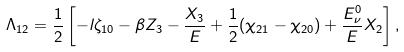Convert formula to latex. <formula><loc_0><loc_0><loc_500><loc_500>\Lambda _ { 1 2 } = \frac { 1 } { 2 } \left [ - l \zeta _ { 1 0 } - \beta Z _ { 3 } - \frac { X _ { 3 } } { E } + \frac { 1 } { 2 } ( \chi _ { 2 1 } - \chi _ { 2 0 } ) + \frac { E _ { \nu } ^ { 0 } } { E } X _ { 2 } \right ] ,</formula> 